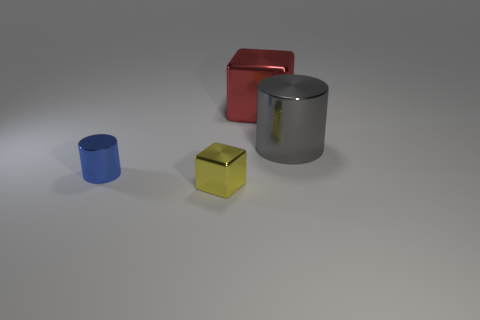Are there fewer small metallic cubes that are left of the blue metallic thing than large gray objects that are in front of the large gray metal object?
Your response must be concise. No. What number of things are metal blocks that are in front of the blue cylinder or tiny things?
Provide a succinct answer. 2. Does the red block have the same size as the shiny cylinder that is to the right of the tiny blue shiny cylinder?
Ensure brevity in your answer.  Yes. What size is the blue object that is the same shape as the big gray shiny object?
Your response must be concise. Small. There is a metal cylinder that is to the right of the block in front of the big red cube; how many metal objects are behind it?
Your answer should be very brief. 1. How many cylinders are either blue rubber things or big things?
Offer a terse response. 1. The thing that is behind the gray object that is in front of the large shiny thing left of the gray cylinder is what color?
Keep it short and to the point. Red. What number of other things are the same size as the blue shiny object?
Make the answer very short. 1. Is there any other thing that is the same shape as the gray thing?
Your response must be concise. Yes. What color is the small thing that is the same shape as the large red metallic thing?
Provide a succinct answer. Yellow. 